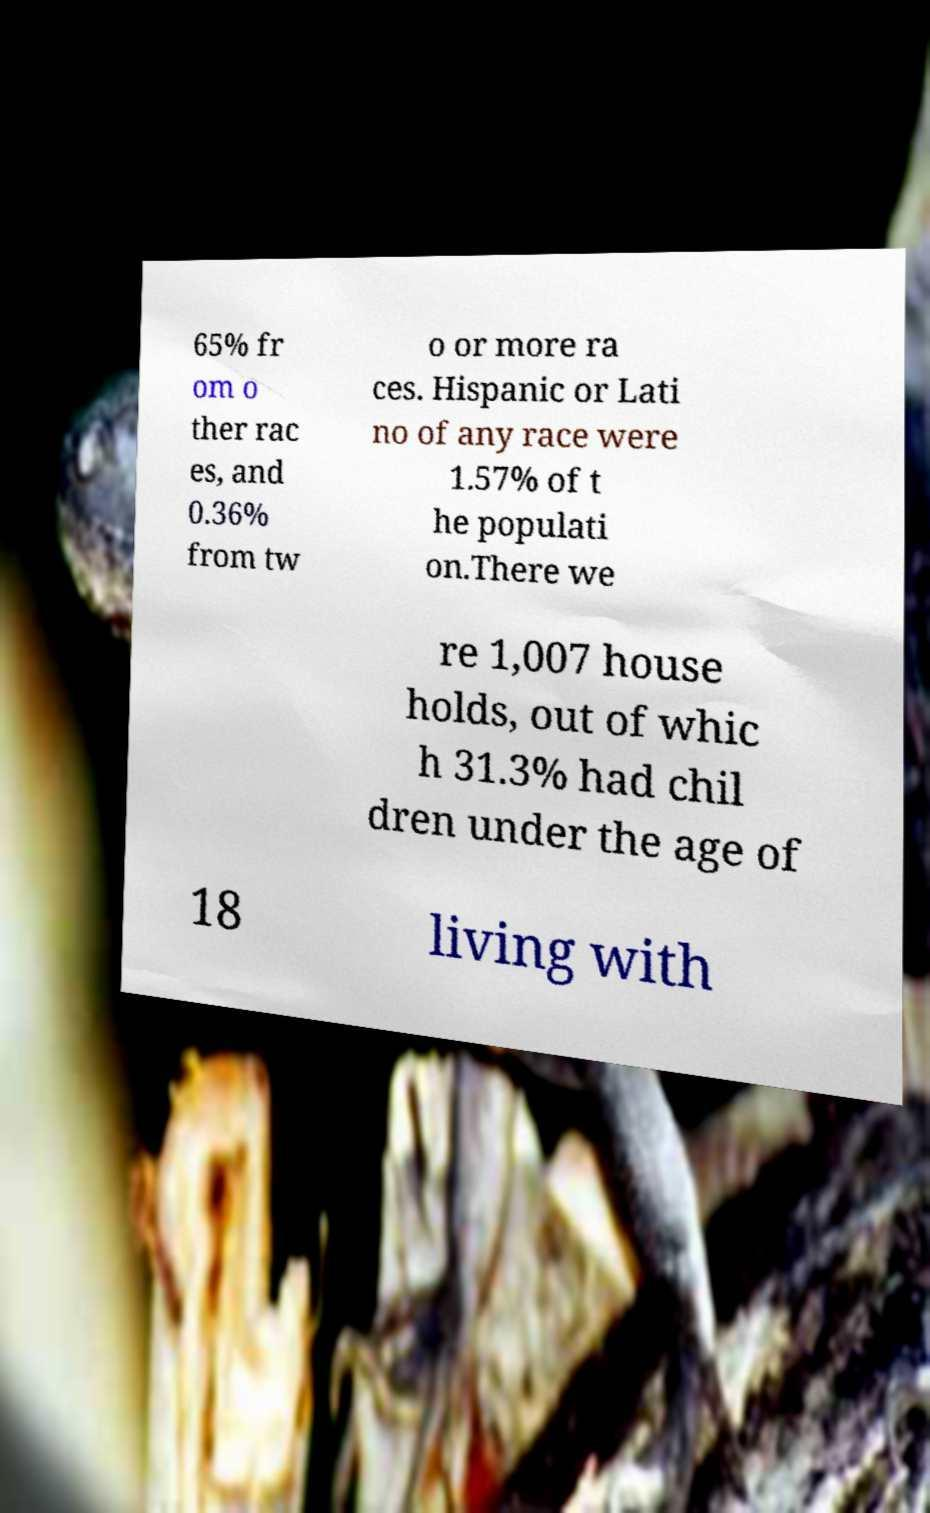I need the written content from this picture converted into text. Can you do that? 65% fr om o ther rac es, and 0.36% from tw o or more ra ces. Hispanic or Lati no of any race were 1.57% of t he populati on.There we re 1,007 house holds, out of whic h 31.3% had chil dren under the age of 18 living with 